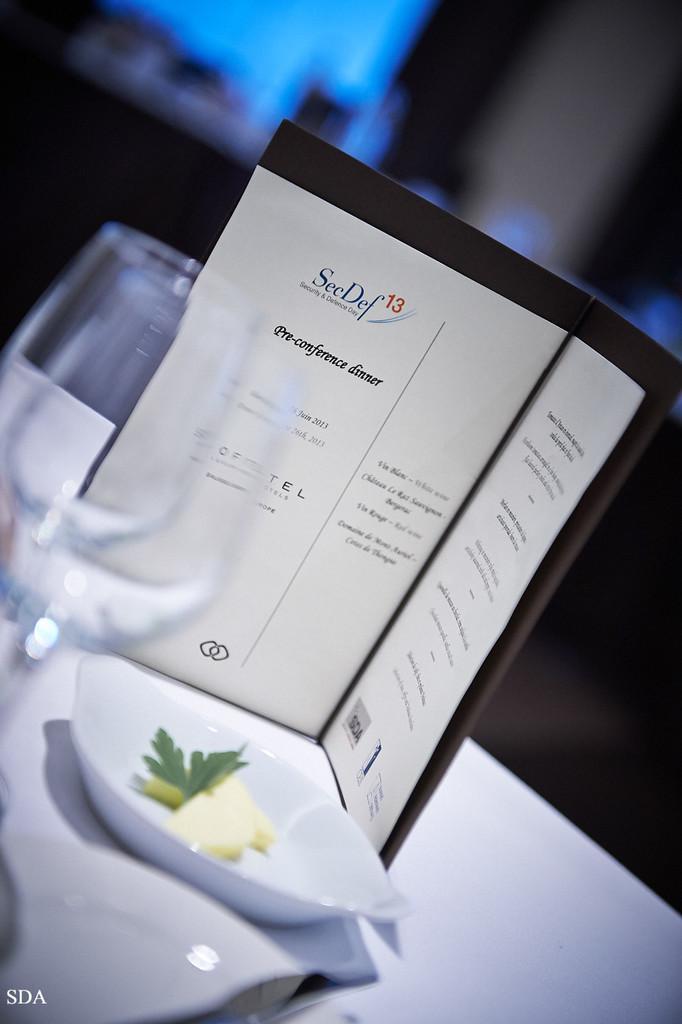Please provide a concise description of this image. In this picture we can see a table, there is a tray, two glasses and a card present on the table, we can see a bowl in this tree, there is some text on this card, we can see pieces of lemon present in this bowl, there is a blurry background. 